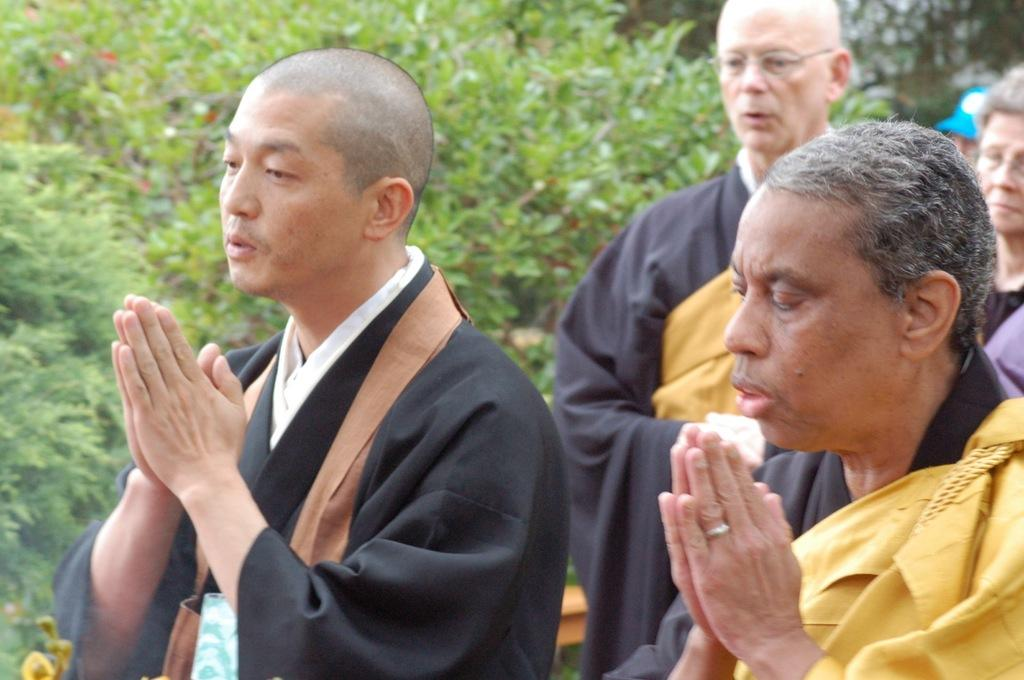How many people are in the image? There is a group of people in the image, but the exact number cannot be determined without more information. What else can be seen in the image besides the group of people? Plants are visible in the image. What type of coast can be seen in the image? There is no coast visible in the image; it features a group of people and plants. What decision was made by the group of people in the image? There is no indication of a decision being made by the group of people in the image. 